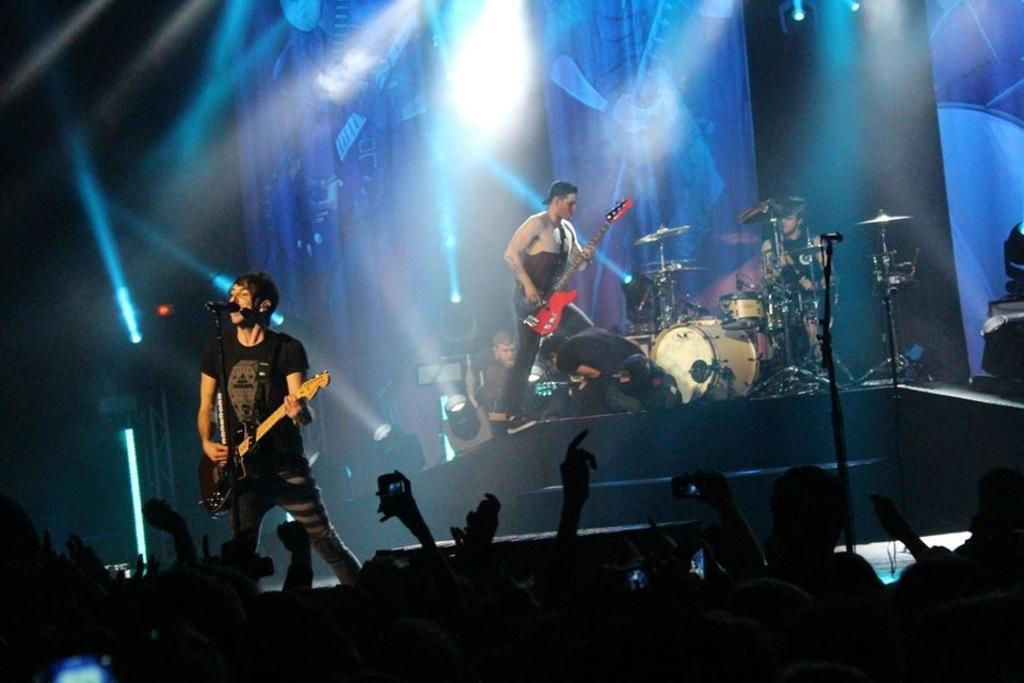In one or two sentences, can you explain what this image depicts? In this image I see a man who is holding a guitar and standing in front of a mic and I can also see there are lot of people over here. In the background I see the lights, few men and the musical instruments. 